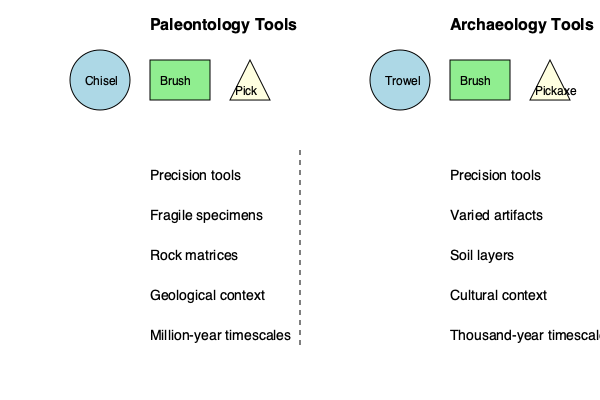Based on the illustrated diagram comparing excavation tools used in paleontology and archaeology, what is the primary shared tool between the two disciplines, and what does this similarity suggest about the nature of their fieldwork? To answer this question, let's analyze the diagram step-by-step:

1. Paleontology Tools:
   - Chisel
   - Brush
   - Pick

2. Archaeology Tools:
   - Trowel
   - Brush
   - Pickaxe

3. Comparison of tools:
   - The brush is the only tool that appears in both sets of equipment.
   - Both disciplines use a variation of a pointed tool (pick for paleontology, pickaxe for archaeology).
   - The chisel (paleontology) and trowel (archaeology) are different but serve similar purposes for precise excavation.

4. Shared characteristics in fieldwork:
   - Both use precision tools
   - Both deal with fragile specimens or artifacts
   - Both work with different types of matrices (rock for paleontology, soil for archaeology)
   - Both consider contextual information (geological vs. cultural)
   - Both work on extended timescales, though paleontology typically deals with much older specimens

5. Significance of the shared brush:
   - The brush is used for careful cleaning and revealing of specimens or artifacts.
   - Its presence in both toolkits suggests that both disciplines require delicate and precise work to avoid damaging their findings.
   - The brush indicates that both fields prioritize the preservation and careful examination of their discoveries.

Given this analysis, the primary shared tool is the brush, and its use in both disciplines suggests that paleontology and archaeology both involve meticulous, gentle excavation techniques to preserve the integrity of their findings.
Answer: Brush; both involve meticulous, gentle excavation techniques. 